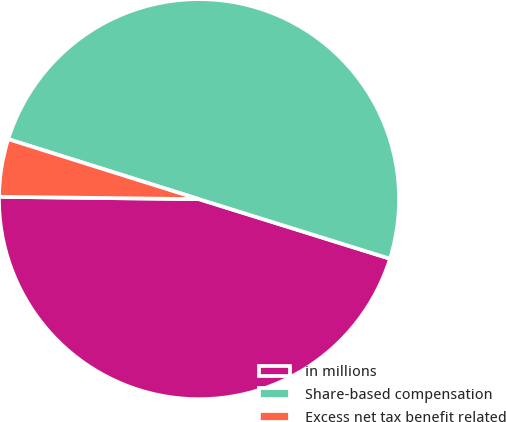Convert chart to OTSL. <chart><loc_0><loc_0><loc_500><loc_500><pie_chart><fcel>in millions<fcel>Share-based compensation<fcel>Excess net tax benefit related<nl><fcel>45.38%<fcel>49.97%<fcel>4.66%<nl></chart> 